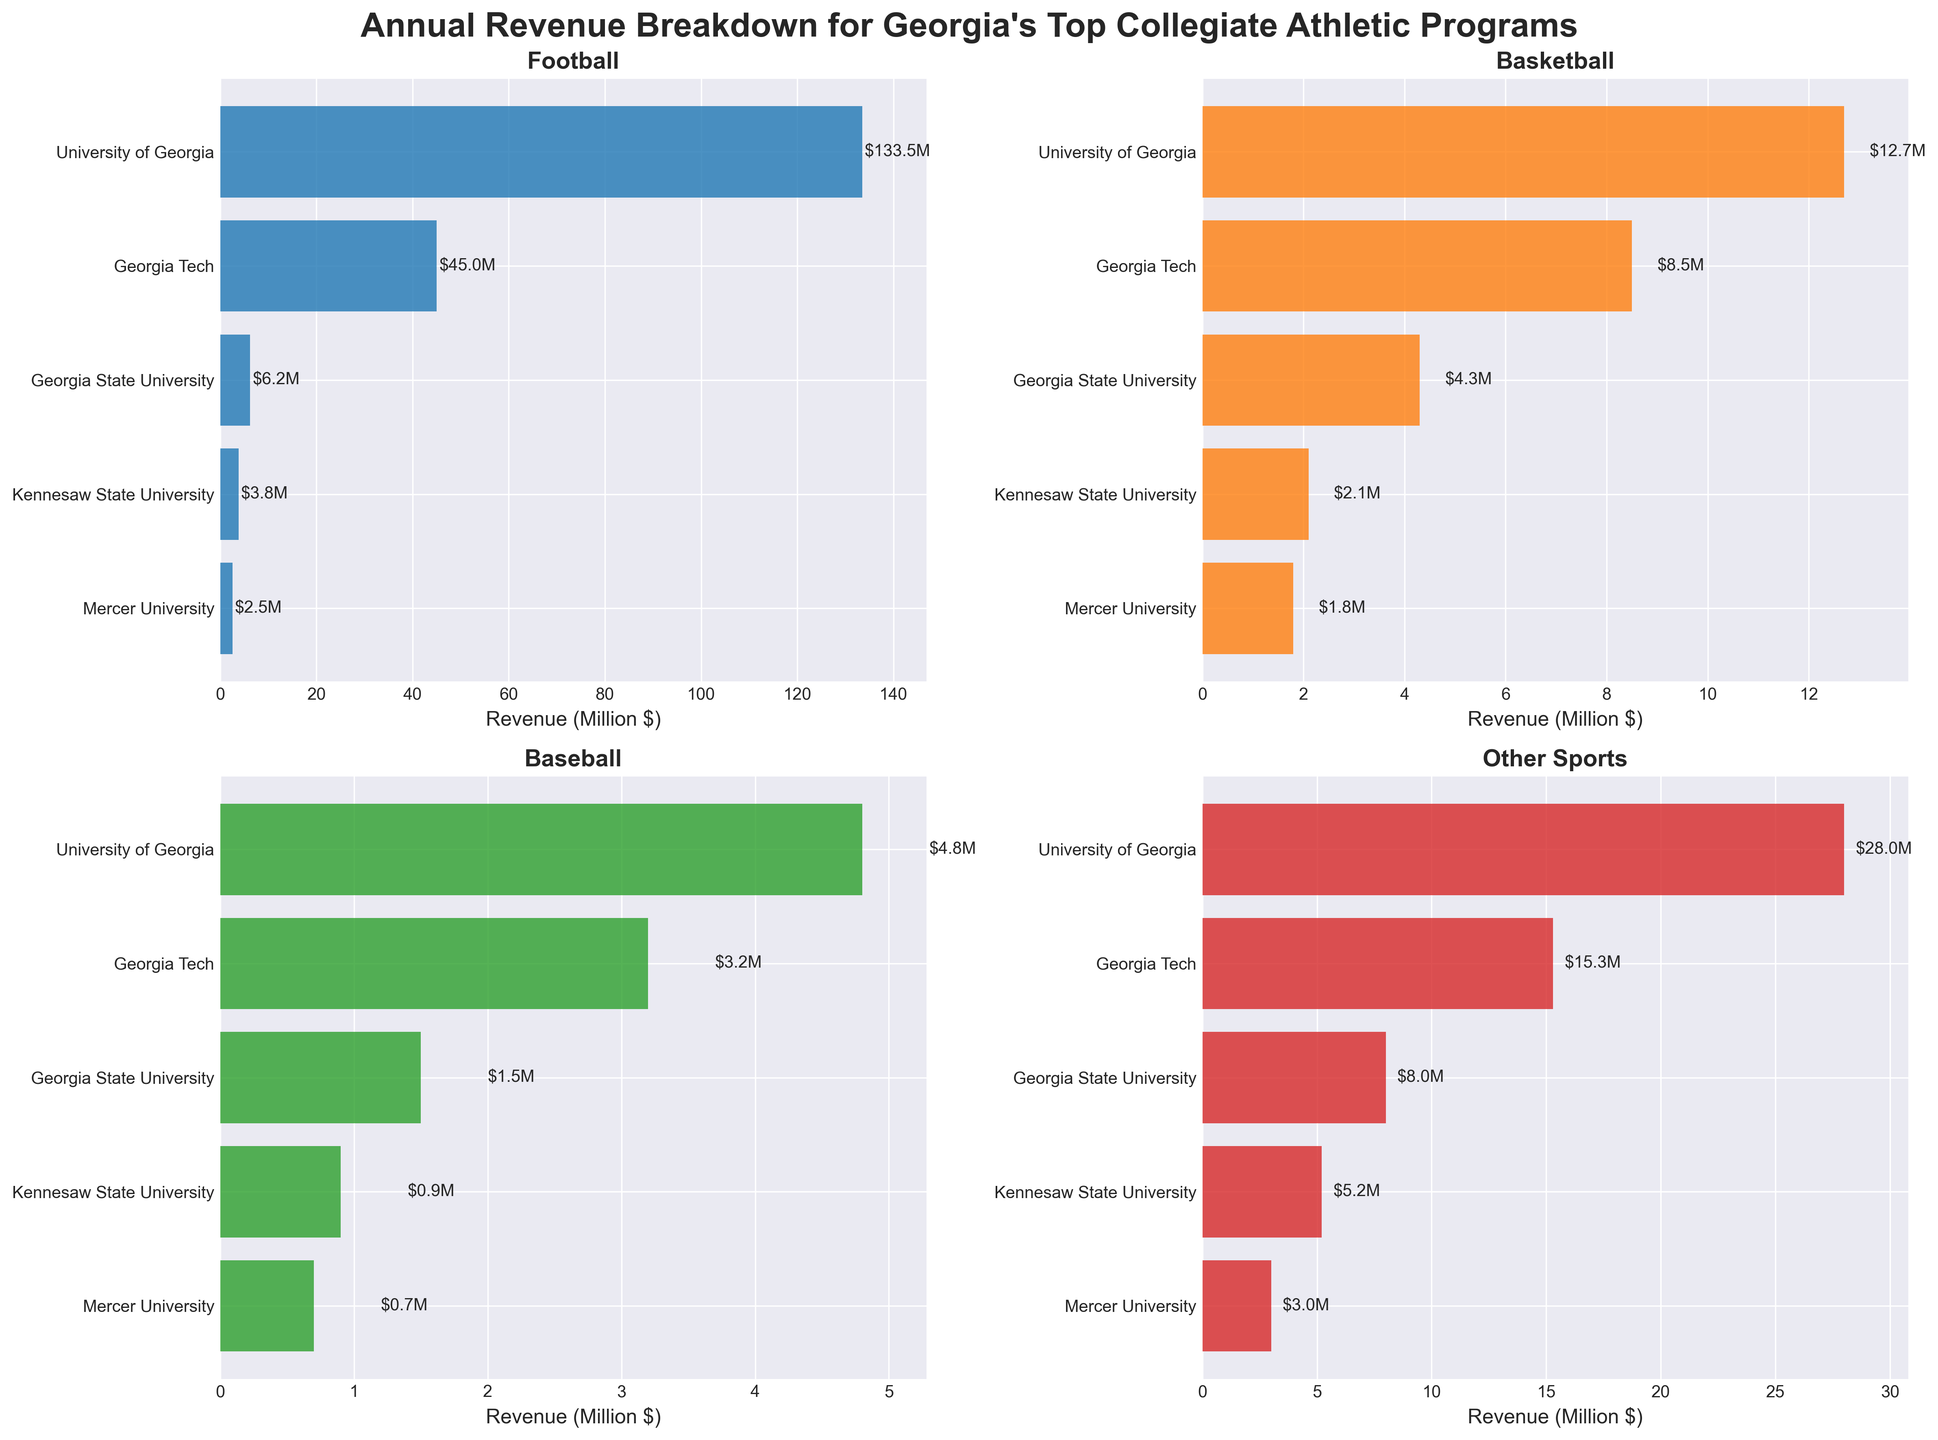How much revenue did the University of Georgia make from Basketball? Refer to the Basketball subplot, find the bar representing University of Georgia, and read the revenue value, which is $12.7M.
Answer: $12.7M Which sporting program generated the highest revenue from Football? Refer to the Football subplot, find the longest bar, which belongs to the University of Georgia with revenue of $133.5M.
Answer: University of Georgia What is the total revenue from Baseball for all programs combined? Add the Baseball revenues from all programs: $4.8M (UGA) + $3.2M (Tech) + $1.5M (GSU) + $0.9M (KSU) + $0.7M (Mercer) = $11.1M.
Answer: $11.1M Which program had the highest total revenue for Other Sports? Refer to the Other Sports subplot, find the longest bar, which belongs to the University of Georgia with revenue of $28M.
Answer: University of Georgia Compare the Basketball revenue of Georgia Tech and Kennesaw State University. Which is higher? Refer to the Basketball subplot, compare the bars for Georgia Tech ($8.5M) and Kennesaw State University ($2.1M). Georgia Tech is higher.
Answer: Georgia Tech What is the average revenue from Football for all programs? Add the Football revenues and divide by the number of programs: ($133.5M + $45M + $6.2M + $3.8M + $2.5M) / 5 = $38.2M.
Answer: $38.2M What is the difference in revenue from Other Sports between Georgia State University and Mercer University? Refer to the Other Sports subplot, subtract Mercer's revenue from Georgia State's revenue: $8M - $3M = $5M.
Answer: $5M Identify the program with the smallest revenue from Baseball. Refer to the Baseball subplot, find the shortest bar, which belongs to Mercer University with revenue of $0.7M.
Answer: Mercer University How does the total revenue of Kennesaw State University compare to Georgia State University across all sports? Add the revenues for each program across all sports and compare: Kennesaw State ($3.8M + $2.1M + $0.9M + $5.2M = $12M), Georgia State ($6.2M + $4.3M + $1.5M + $8M = $20M). Georgia State has higher total revenue.
Answer: Georgia State University How much more revenue does Football generate compared to Basketball for the University of Georgia? Subtract Basketball revenue from Football revenue for the University of Georgia: $133.5M - $12.7M = $120.8M.
Answer: $120.8M 